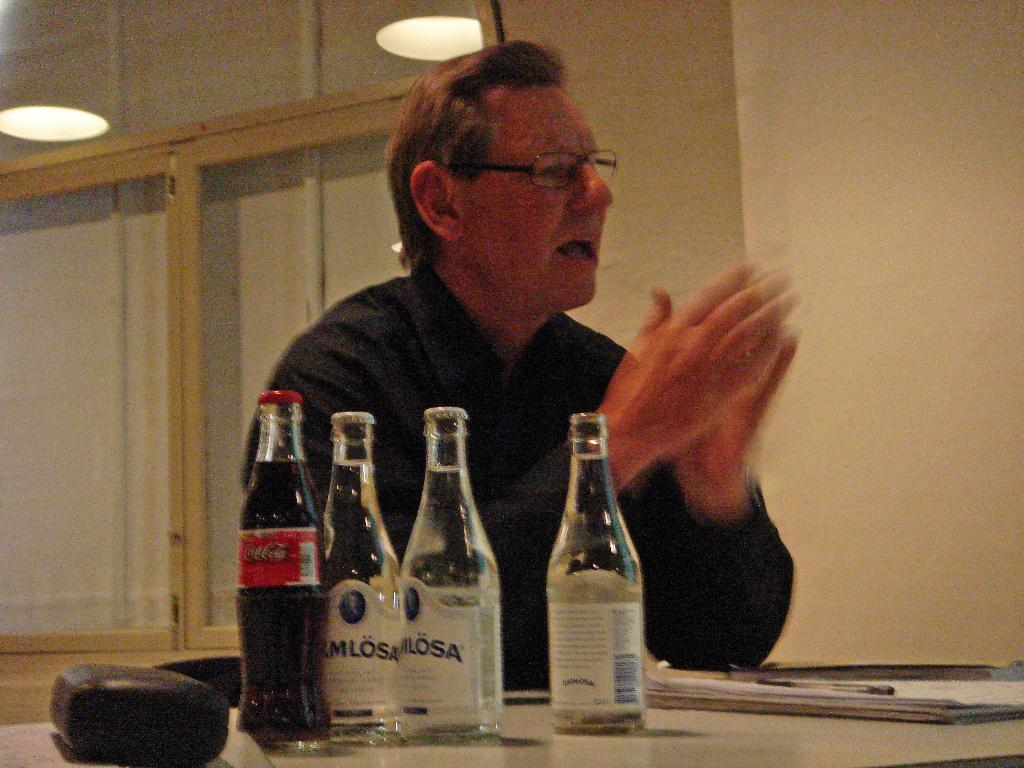Provide a one-sentence caption for the provided image. A man sits at a table with 3 bottles of water and a Coca Cola bottle near him. 